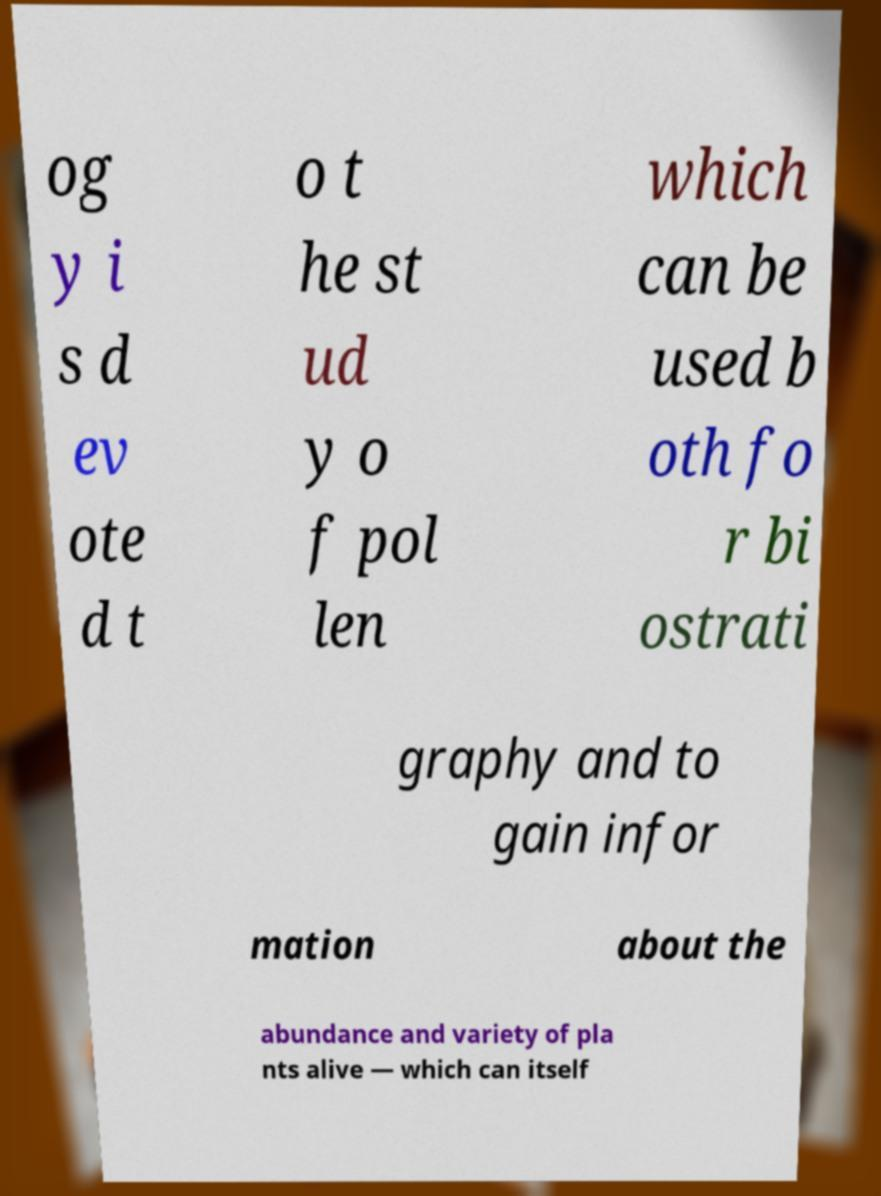Could you assist in decoding the text presented in this image and type it out clearly? og y i s d ev ote d t o t he st ud y o f pol len which can be used b oth fo r bi ostrati graphy and to gain infor mation about the abundance and variety of pla nts alive — which can itself 